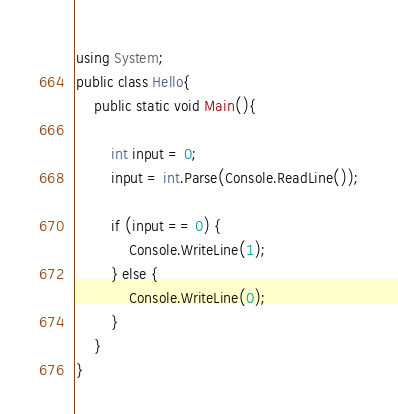<code> <loc_0><loc_0><loc_500><loc_500><_C#_>using System;
public class Hello{
    public static void Main(){
        
        int input = 0;
        input = int.Parse(Console.ReadLine());
        
        if (input == 0) {
            Console.WriteLine(1);
        } else {
            Console.WriteLine(0);
        }
    }
}</code> 